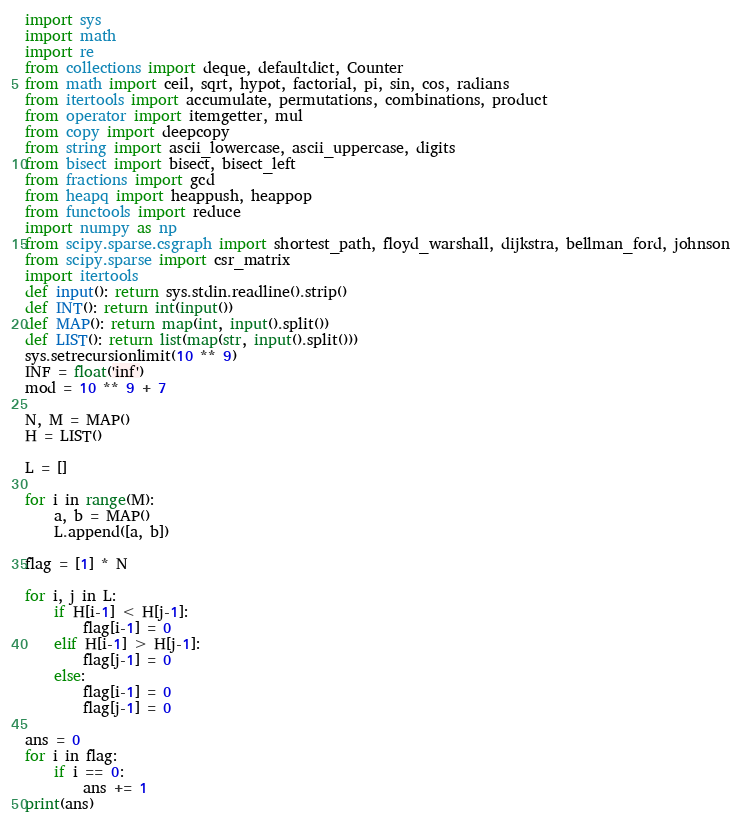<code> <loc_0><loc_0><loc_500><loc_500><_Python_>import sys
import math
import re
from collections import deque, defaultdict, Counter
from math import ceil, sqrt, hypot, factorial, pi, sin, cos, radians
from itertools import accumulate, permutations, combinations, product
from operator import itemgetter, mul
from copy import deepcopy
from string import ascii_lowercase, ascii_uppercase, digits
from bisect import bisect, bisect_left
from fractions import gcd
from heapq import heappush, heappop
from functools import reduce
import numpy as np
from scipy.sparse.csgraph import shortest_path, floyd_warshall, dijkstra, bellman_ford, johnson
from scipy.sparse import csr_matrix
import itertools
def input(): return sys.stdin.readline().strip()
def INT(): return int(input())
def MAP(): return map(int, input().split())
def LIST(): return list(map(str, input().split()))
sys.setrecursionlimit(10 ** 9)
INF = float('inf')
mod = 10 ** 9 + 7

N, M = MAP()
H = LIST()

L = []

for i in range(M):
    a, b = MAP()
    L.append([a, b])

flag = [1] * N

for i, j in L:
    if H[i-1] < H[j-1]:
        flag[i-1] = 0
    elif H[i-1] > H[j-1]:
        flag[j-1] = 0
    else:
        flag[i-1] = 0
        flag[j-1] = 0

ans = 0
for i in flag:
    if i == 0:
        ans += 1
print(ans)
</code> 